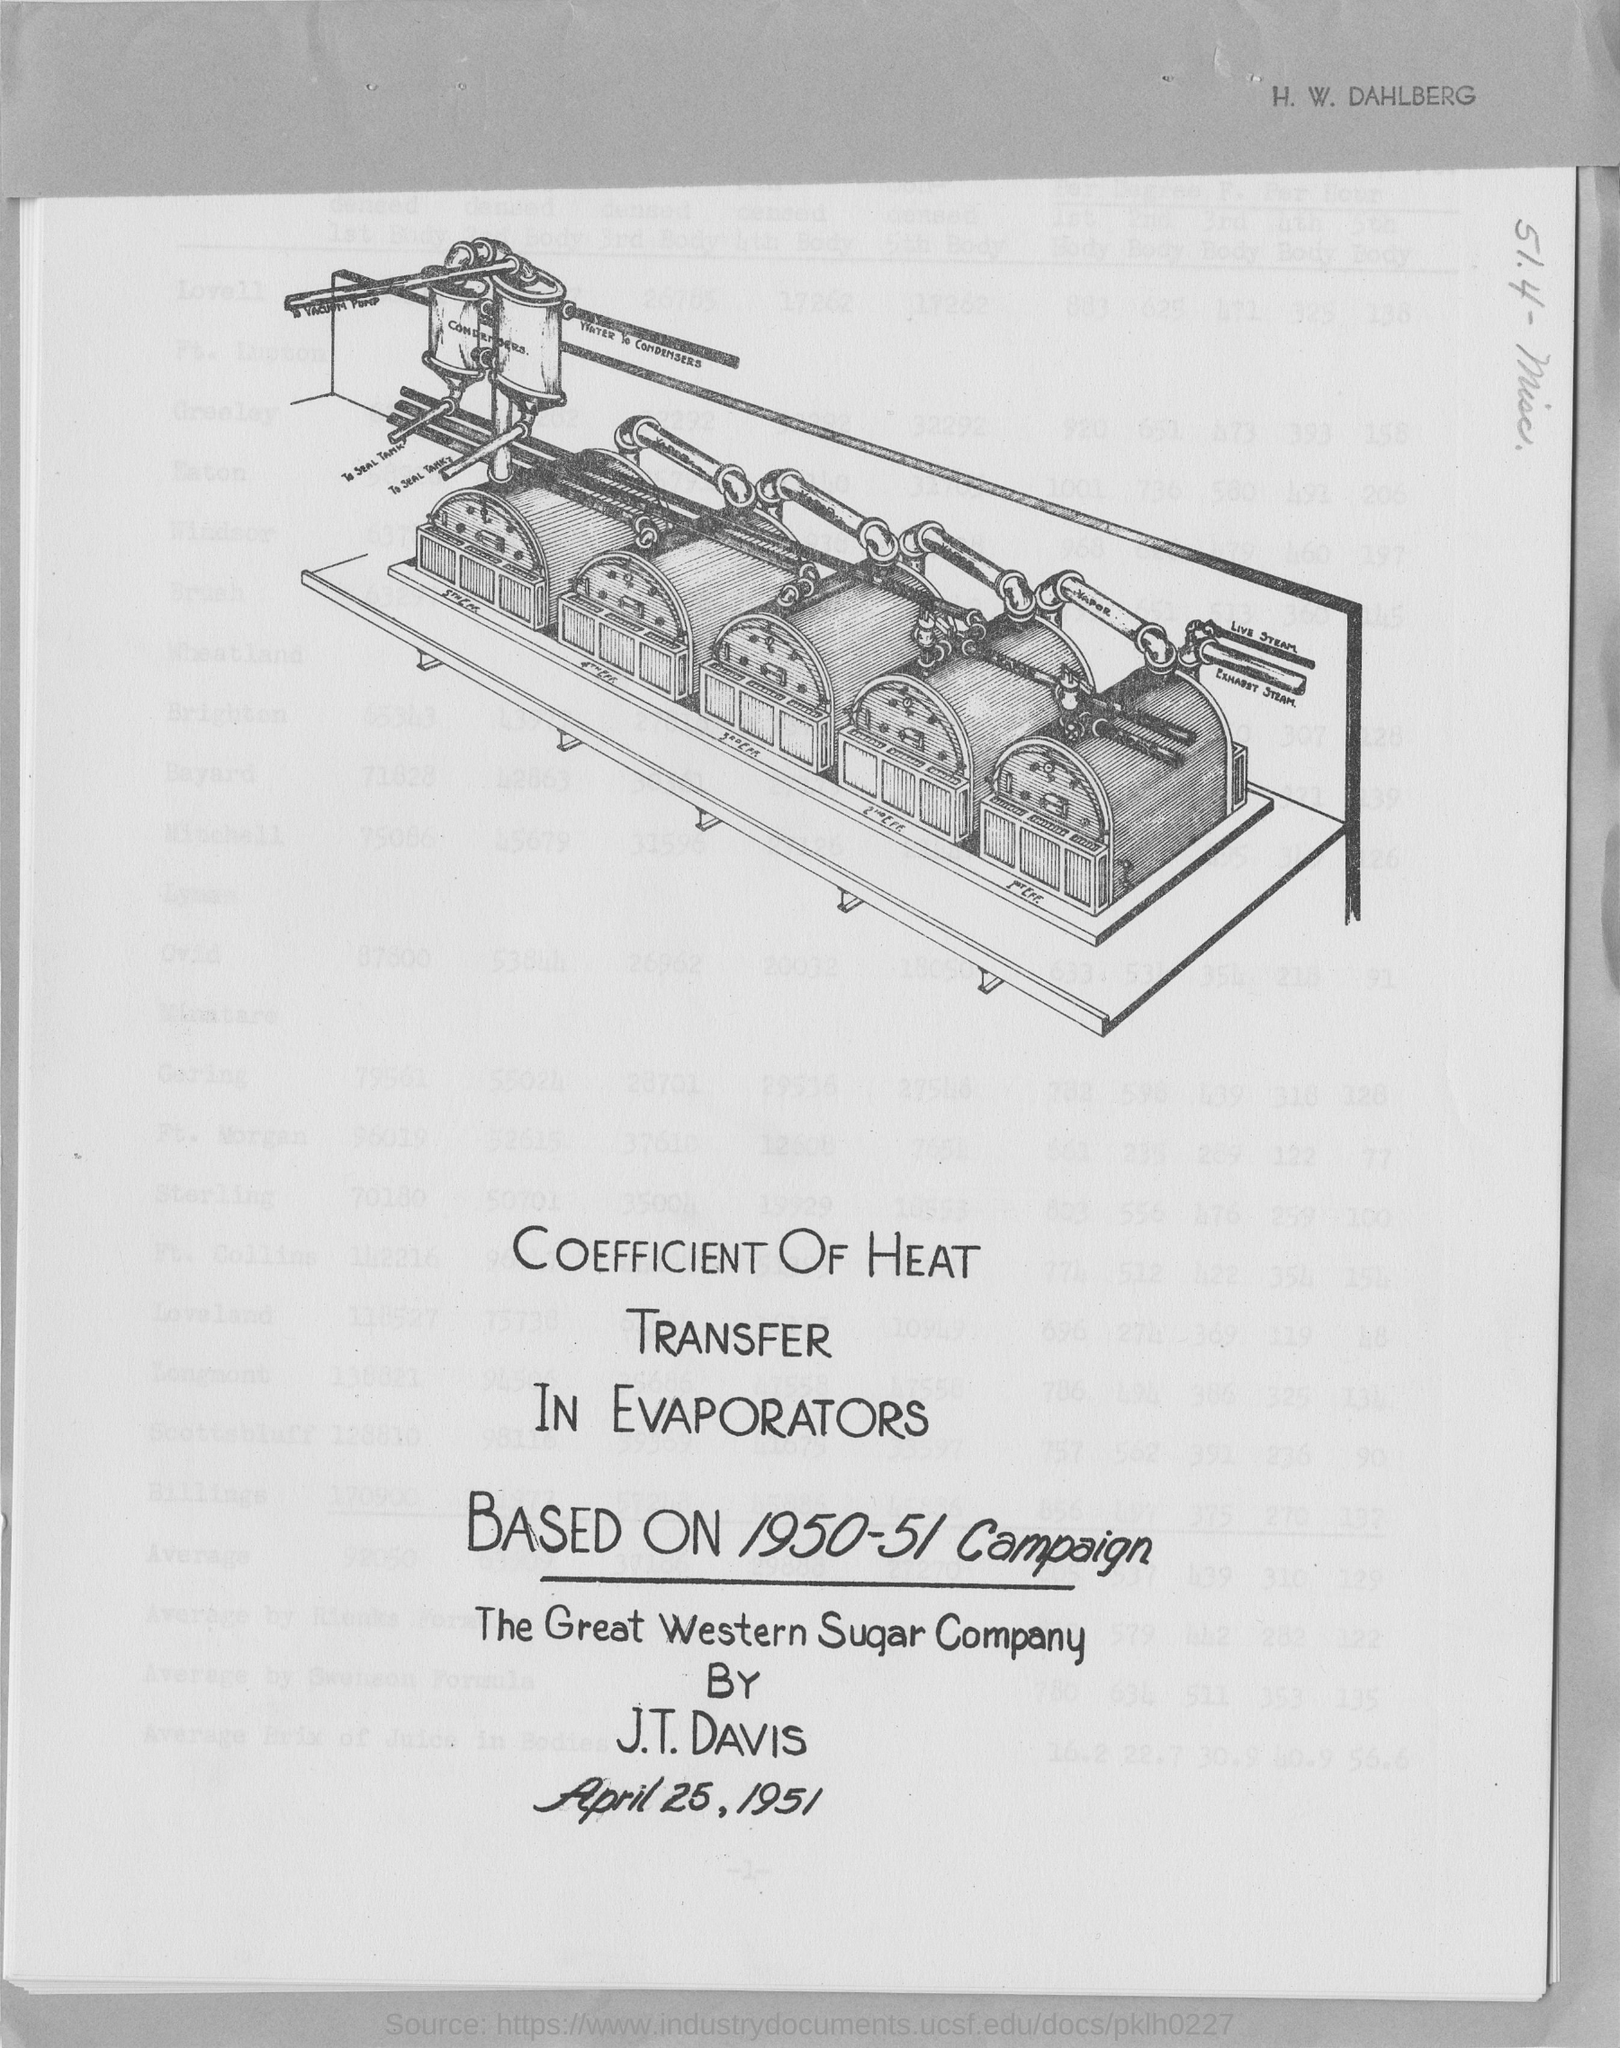What is the date mentioned in this document?
Give a very brief answer. April 25, 1951. 